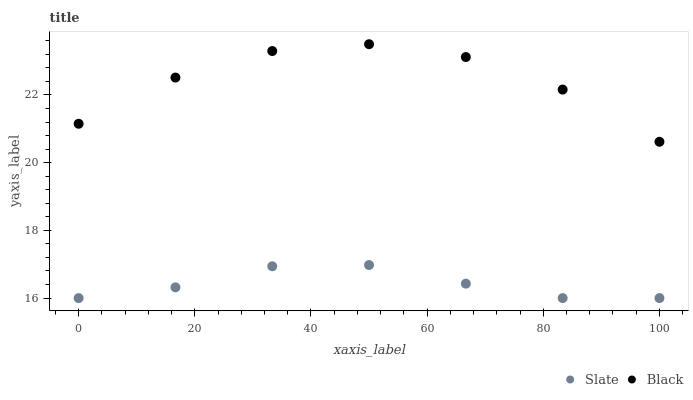Does Slate have the minimum area under the curve?
Answer yes or no. Yes. Does Black have the maximum area under the curve?
Answer yes or no. Yes. Does Black have the minimum area under the curve?
Answer yes or no. No. Is Slate the smoothest?
Answer yes or no. Yes. Is Black the roughest?
Answer yes or no. Yes. Is Black the smoothest?
Answer yes or no. No. Does Slate have the lowest value?
Answer yes or no. Yes. Does Black have the lowest value?
Answer yes or no. No. Does Black have the highest value?
Answer yes or no. Yes. Is Slate less than Black?
Answer yes or no. Yes. Is Black greater than Slate?
Answer yes or no. Yes. Does Slate intersect Black?
Answer yes or no. No. 